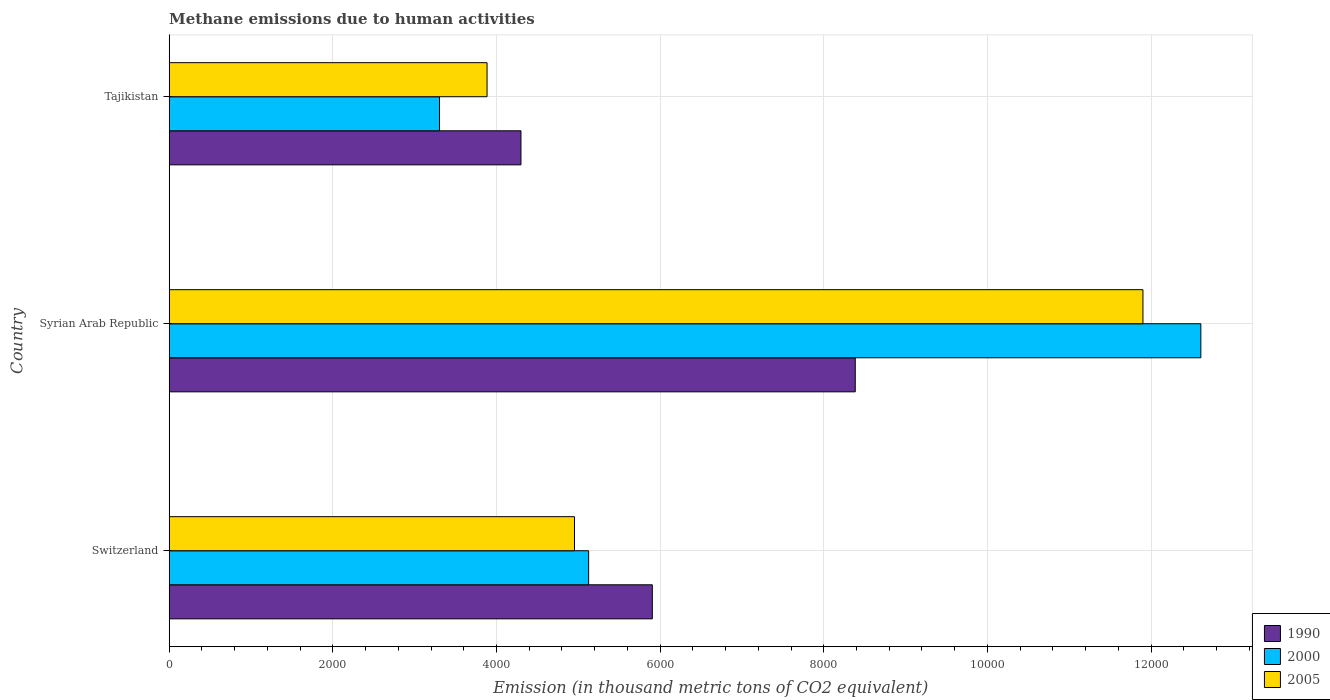How many different coloured bars are there?
Your answer should be compact. 3. How many bars are there on the 3rd tick from the bottom?
Keep it short and to the point. 3. What is the label of the 2nd group of bars from the top?
Provide a short and direct response. Syrian Arab Republic. In how many cases, is the number of bars for a given country not equal to the number of legend labels?
Make the answer very short. 0. What is the amount of methane emitted in 2000 in Switzerland?
Your answer should be compact. 5126.2. Across all countries, what is the maximum amount of methane emitted in 2000?
Offer a very short reply. 1.26e+04. Across all countries, what is the minimum amount of methane emitted in 2005?
Ensure brevity in your answer.  3884.9. In which country was the amount of methane emitted in 2005 maximum?
Offer a very short reply. Syrian Arab Republic. In which country was the amount of methane emitted in 2005 minimum?
Your response must be concise. Tajikistan. What is the total amount of methane emitted in 1990 in the graph?
Make the answer very short. 1.86e+04. What is the difference between the amount of methane emitted in 2000 in Syrian Arab Republic and that in Tajikistan?
Provide a short and direct response. 9305.2. What is the difference between the amount of methane emitted in 2005 in Switzerland and the amount of methane emitted in 1990 in Tajikistan?
Your response must be concise. 654.4. What is the average amount of methane emitted in 2005 per country?
Make the answer very short. 6913.17. What is the difference between the amount of methane emitted in 2000 and amount of methane emitted in 2005 in Syrian Arab Republic?
Provide a succinct answer. 707.6. What is the ratio of the amount of methane emitted in 2000 in Syrian Arab Republic to that in Tajikistan?
Offer a terse response. 3.82. Is the amount of methane emitted in 2000 in Switzerland less than that in Tajikistan?
Provide a succinct answer. No. What is the difference between the highest and the second highest amount of methane emitted in 2000?
Provide a short and direct response. 7482.6. What is the difference between the highest and the lowest amount of methane emitted in 2000?
Your answer should be compact. 9305.2. In how many countries, is the amount of methane emitted in 2005 greater than the average amount of methane emitted in 2005 taken over all countries?
Offer a very short reply. 1. What does the 3rd bar from the top in Syrian Arab Republic represents?
Offer a very short reply. 1990. What does the 3rd bar from the bottom in Tajikistan represents?
Your answer should be compact. 2005. Is it the case that in every country, the sum of the amount of methane emitted in 2005 and amount of methane emitted in 2000 is greater than the amount of methane emitted in 1990?
Your response must be concise. Yes. How many bars are there?
Give a very brief answer. 9. How many countries are there in the graph?
Ensure brevity in your answer.  3. Are the values on the major ticks of X-axis written in scientific E-notation?
Make the answer very short. No. Does the graph contain any zero values?
Ensure brevity in your answer.  No. What is the title of the graph?
Provide a short and direct response. Methane emissions due to human activities. What is the label or title of the X-axis?
Offer a terse response. Emission (in thousand metric tons of CO2 equivalent). What is the label or title of the Y-axis?
Keep it short and to the point. Country. What is the Emission (in thousand metric tons of CO2 equivalent) in 1990 in Switzerland?
Your response must be concise. 5904.8. What is the Emission (in thousand metric tons of CO2 equivalent) in 2000 in Switzerland?
Provide a short and direct response. 5126.2. What is the Emission (in thousand metric tons of CO2 equivalent) in 2005 in Switzerland?
Your answer should be compact. 4953.4. What is the Emission (in thousand metric tons of CO2 equivalent) in 1990 in Syrian Arab Republic?
Provide a short and direct response. 8384.9. What is the Emission (in thousand metric tons of CO2 equivalent) in 2000 in Syrian Arab Republic?
Provide a succinct answer. 1.26e+04. What is the Emission (in thousand metric tons of CO2 equivalent) in 2005 in Syrian Arab Republic?
Provide a succinct answer. 1.19e+04. What is the Emission (in thousand metric tons of CO2 equivalent) in 1990 in Tajikistan?
Give a very brief answer. 4299. What is the Emission (in thousand metric tons of CO2 equivalent) in 2000 in Tajikistan?
Your answer should be compact. 3303.6. What is the Emission (in thousand metric tons of CO2 equivalent) in 2005 in Tajikistan?
Provide a succinct answer. 3884.9. Across all countries, what is the maximum Emission (in thousand metric tons of CO2 equivalent) of 1990?
Keep it short and to the point. 8384.9. Across all countries, what is the maximum Emission (in thousand metric tons of CO2 equivalent) in 2000?
Ensure brevity in your answer.  1.26e+04. Across all countries, what is the maximum Emission (in thousand metric tons of CO2 equivalent) in 2005?
Give a very brief answer. 1.19e+04. Across all countries, what is the minimum Emission (in thousand metric tons of CO2 equivalent) in 1990?
Your answer should be very brief. 4299. Across all countries, what is the minimum Emission (in thousand metric tons of CO2 equivalent) in 2000?
Offer a very short reply. 3303.6. Across all countries, what is the minimum Emission (in thousand metric tons of CO2 equivalent) of 2005?
Ensure brevity in your answer.  3884.9. What is the total Emission (in thousand metric tons of CO2 equivalent) in 1990 in the graph?
Keep it short and to the point. 1.86e+04. What is the total Emission (in thousand metric tons of CO2 equivalent) in 2000 in the graph?
Your answer should be very brief. 2.10e+04. What is the total Emission (in thousand metric tons of CO2 equivalent) of 2005 in the graph?
Ensure brevity in your answer.  2.07e+04. What is the difference between the Emission (in thousand metric tons of CO2 equivalent) in 1990 in Switzerland and that in Syrian Arab Republic?
Your answer should be very brief. -2480.1. What is the difference between the Emission (in thousand metric tons of CO2 equivalent) in 2000 in Switzerland and that in Syrian Arab Republic?
Give a very brief answer. -7482.6. What is the difference between the Emission (in thousand metric tons of CO2 equivalent) of 2005 in Switzerland and that in Syrian Arab Republic?
Ensure brevity in your answer.  -6947.8. What is the difference between the Emission (in thousand metric tons of CO2 equivalent) of 1990 in Switzerland and that in Tajikistan?
Your answer should be compact. 1605.8. What is the difference between the Emission (in thousand metric tons of CO2 equivalent) of 2000 in Switzerland and that in Tajikistan?
Provide a short and direct response. 1822.6. What is the difference between the Emission (in thousand metric tons of CO2 equivalent) in 2005 in Switzerland and that in Tajikistan?
Make the answer very short. 1068.5. What is the difference between the Emission (in thousand metric tons of CO2 equivalent) of 1990 in Syrian Arab Republic and that in Tajikistan?
Make the answer very short. 4085.9. What is the difference between the Emission (in thousand metric tons of CO2 equivalent) of 2000 in Syrian Arab Republic and that in Tajikistan?
Your response must be concise. 9305.2. What is the difference between the Emission (in thousand metric tons of CO2 equivalent) in 2005 in Syrian Arab Republic and that in Tajikistan?
Provide a succinct answer. 8016.3. What is the difference between the Emission (in thousand metric tons of CO2 equivalent) in 1990 in Switzerland and the Emission (in thousand metric tons of CO2 equivalent) in 2000 in Syrian Arab Republic?
Offer a terse response. -6704. What is the difference between the Emission (in thousand metric tons of CO2 equivalent) in 1990 in Switzerland and the Emission (in thousand metric tons of CO2 equivalent) in 2005 in Syrian Arab Republic?
Provide a short and direct response. -5996.4. What is the difference between the Emission (in thousand metric tons of CO2 equivalent) of 2000 in Switzerland and the Emission (in thousand metric tons of CO2 equivalent) of 2005 in Syrian Arab Republic?
Your answer should be compact. -6775. What is the difference between the Emission (in thousand metric tons of CO2 equivalent) in 1990 in Switzerland and the Emission (in thousand metric tons of CO2 equivalent) in 2000 in Tajikistan?
Your answer should be compact. 2601.2. What is the difference between the Emission (in thousand metric tons of CO2 equivalent) in 1990 in Switzerland and the Emission (in thousand metric tons of CO2 equivalent) in 2005 in Tajikistan?
Offer a terse response. 2019.9. What is the difference between the Emission (in thousand metric tons of CO2 equivalent) in 2000 in Switzerland and the Emission (in thousand metric tons of CO2 equivalent) in 2005 in Tajikistan?
Offer a terse response. 1241.3. What is the difference between the Emission (in thousand metric tons of CO2 equivalent) of 1990 in Syrian Arab Republic and the Emission (in thousand metric tons of CO2 equivalent) of 2000 in Tajikistan?
Your answer should be very brief. 5081.3. What is the difference between the Emission (in thousand metric tons of CO2 equivalent) in 1990 in Syrian Arab Republic and the Emission (in thousand metric tons of CO2 equivalent) in 2005 in Tajikistan?
Make the answer very short. 4500. What is the difference between the Emission (in thousand metric tons of CO2 equivalent) in 2000 in Syrian Arab Republic and the Emission (in thousand metric tons of CO2 equivalent) in 2005 in Tajikistan?
Ensure brevity in your answer.  8723.9. What is the average Emission (in thousand metric tons of CO2 equivalent) in 1990 per country?
Your response must be concise. 6196.23. What is the average Emission (in thousand metric tons of CO2 equivalent) of 2000 per country?
Your answer should be very brief. 7012.87. What is the average Emission (in thousand metric tons of CO2 equivalent) in 2005 per country?
Ensure brevity in your answer.  6913.17. What is the difference between the Emission (in thousand metric tons of CO2 equivalent) in 1990 and Emission (in thousand metric tons of CO2 equivalent) in 2000 in Switzerland?
Provide a succinct answer. 778.6. What is the difference between the Emission (in thousand metric tons of CO2 equivalent) in 1990 and Emission (in thousand metric tons of CO2 equivalent) in 2005 in Switzerland?
Make the answer very short. 951.4. What is the difference between the Emission (in thousand metric tons of CO2 equivalent) of 2000 and Emission (in thousand metric tons of CO2 equivalent) of 2005 in Switzerland?
Your answer should be very brief. 172.8. What is the difference between the Emission (in thousand metric tons of CO2 equivalent) of 1990 and Emission (in thousand metric tons of CO2 equivalent) of 2000 in Syrian Arab Republic?
Keep it short and to the point. -4223.9. What is the difference between the Emission (in thousand metric tons of CO2 equivalent) of 1990 and Emission (in thousand metric tons of CO2 equivalent) of 2005 in Syrian Arab Republic?
Ensure brevity in your answer.  -3516.3. What is the difference between the Emission (in thousand metric tons of CO2 equivalent) of 2000 and Emission (in thousand metric tons of CO2 equivalent) of 2005 in Syrian Arab Republic?
Offer a terse response. 707.6. What is the difference between the Emission (in thousand metric tons of CO2 equivalent) in 1990 and Emission (in thousand metric tons of CO2 equivalent) in 2000 in Tajikistan?
Your answer should be very brief. 995.4. What is the difference between the Emission (in thousand metric tons of CO2 equivalent) in 1990 and Emission (in thousand metric tons of CO2 equivalent) in 2005 in Tajikistan?
Your answer should be compact. 414.1. What is the difference between the Emission (in thousand metric tons of CO2 equivalent) of 2000 and Emission (in thousand metric tons of CO2 equivalent) of 2005 in Tajikistan?
Ensure brevity in your answer.  -581.3. What is the ratio of the Emission (in thousand metric tons of CO2 equivalent) of 1990 in Switzerland to that in Syrian Arab Republic?
Offer a terse response. 0.7. What is the ratio of the Emission (in thousand metric tons of CO2 equivalent) in 2000 in Switzerland to that in Syrian Arab Republic?
Ensure brevity in your answer.  0.41. What is the ratio of the Emission (in thousand metric tons of CO2 equivalent) of 2005 in Switzerland to that in Syrian Arab Republic?
Make the answer very short. 0.42. What is the ratio of the Emission (in thousand metric tons of CO2 equivalent) in 1990 in Switzerland to that in Tajikistan?
Your answer should be compact. 1.37. What is the ratio of the Emission (in thousand metric tons of CO2 equivalent) in 2000 in Switzerland to that in Tajikistan?
Ensure brevity in your answer.  1.55. What is the ratio of the Emission (in thousand metric tons of CO2 equivalent) in 2005 in Switzerland to that in Tajikistan?
Your response must be concise. 1.27. What is the ratio of the Emission (in thousand metric tons of CO2 equivalent) in 1990 in Syrian Arab Republic to that in Tajikistan?
Offer a very short reply. 1.95. What is the ratio of the Emission (in thousand metric tons of CO2 equivalent) in 2000 in Syrian Arab Republic to that in Tajikistan?
Offer a very short reply. 3.82. What is the ratio of the Emission (in thousand metric tons of CO2 equivalent) in 2005 in Syrian Arab Republic to that in Tajikistan?
Your answer should be compact. 3.06. What is the difference between the highest and the second highest Emission (in thousand metric tons of CO2 equivalent) of 1990?
Offer a very short reply. 2480.1. What is the difference between the highest and the second highest Emission (in thousand metric tons of CO2 equivalent) of 2000?
Make the answer very short. 7482.6. What is the difference between the highest and the second highest Emission (in thousand metric tons of CO2 equivalent) of 2005?
Offer a terse response. 6947.8. What is the difference between the highest and the lowest Emission (in thousand metric tons of CO2 equivalent) of 1990?
Your answer should be very brief. 4085.9. What is the difference between the highest and the lowest Emission (in thousand metric tons of CO2 equivalent) in 2000?
Keep it short and to the point. 9305.2. What is the difference between the highest and the lowest Emission (in thousand metric tons of CO2 equivalent) in 2005?
Provide a short and direct response. 8016.3. 